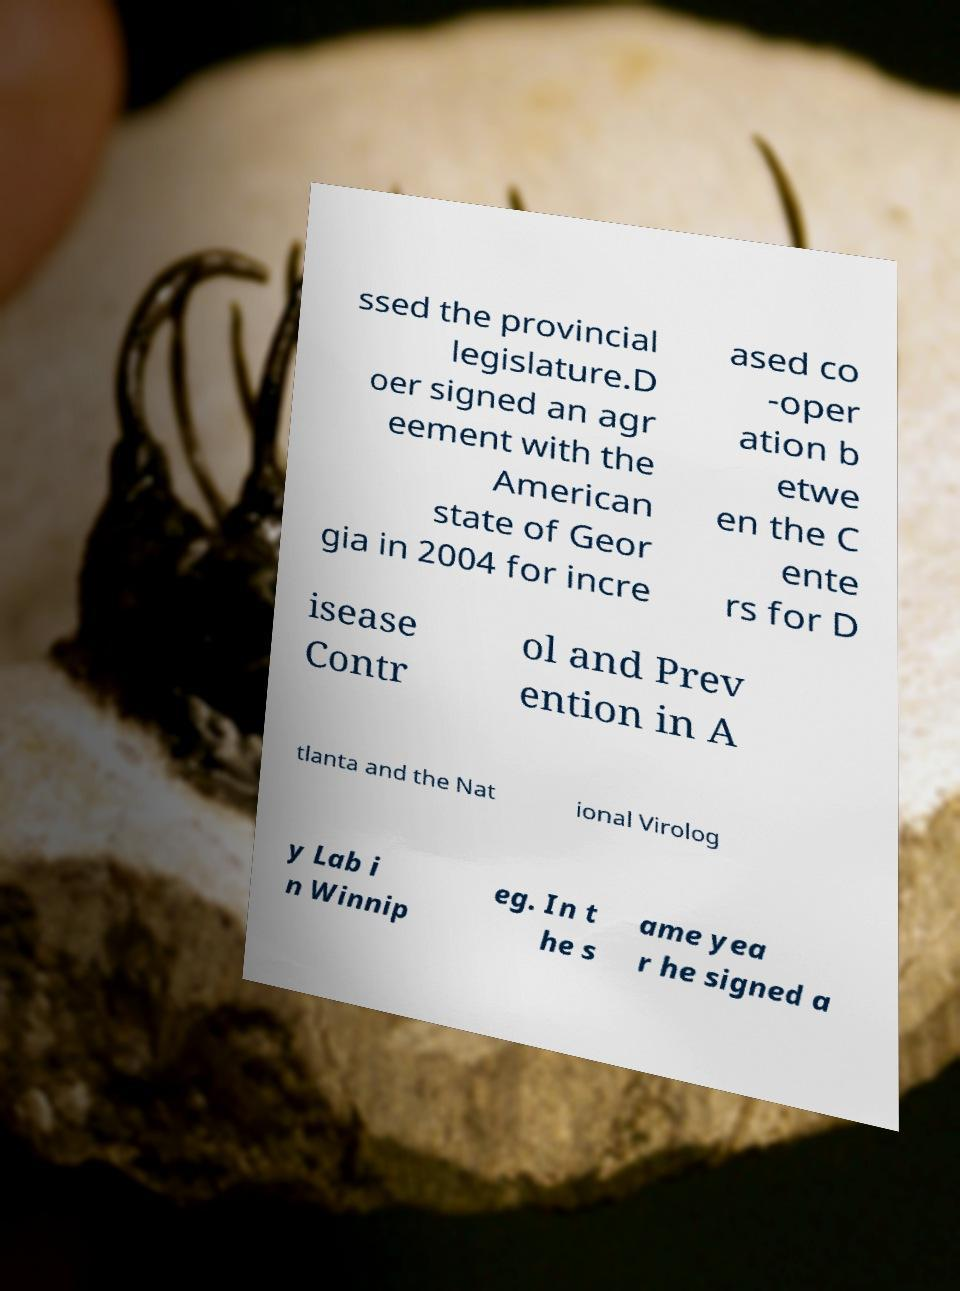Please identify and transcribe the text found in this image. ssed the provincial legislature.D oer signed an agr eement with the American state of Geor gia in 2004 for incre ased co -oper ation b etwe en the C ente rs for D isease Contr ol and Prev ention in A tlanta and the Nat ional Virolog y Lab i n Winnip eg. In t he s ame yea r he signed a 